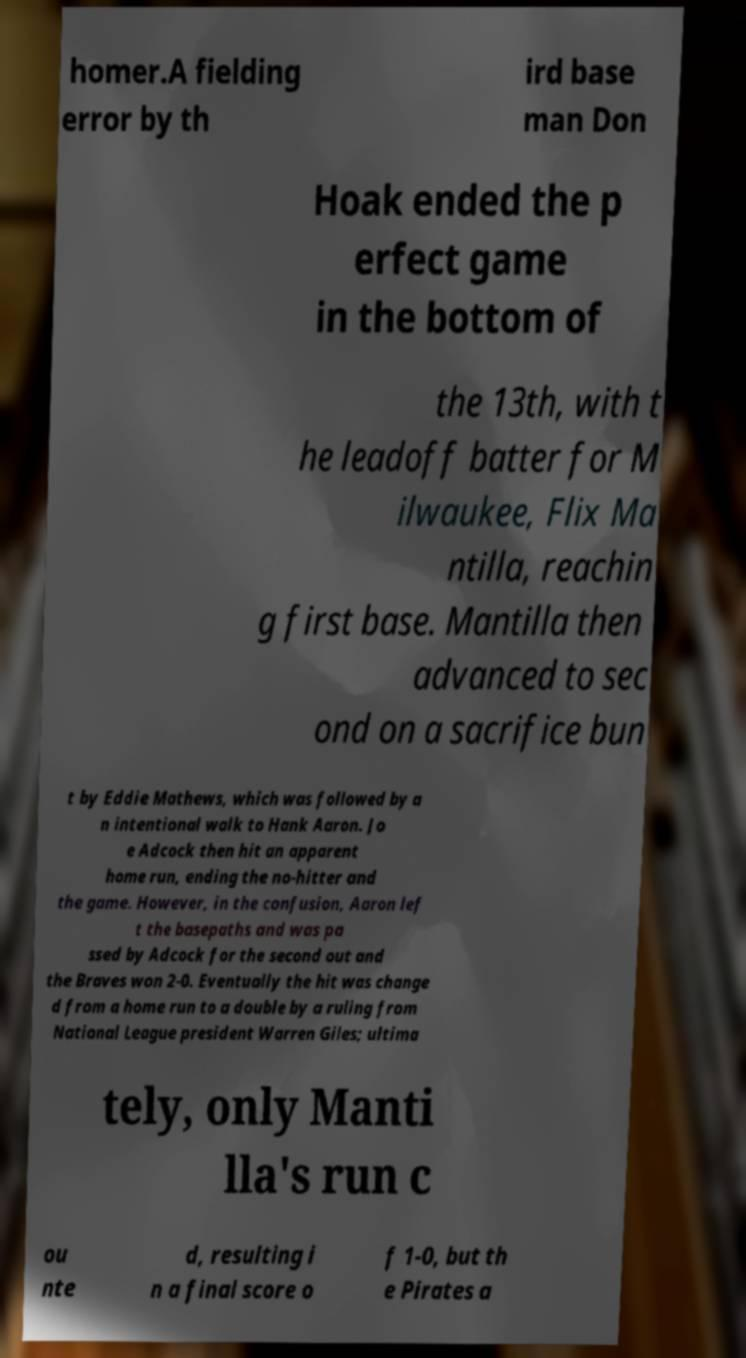For documentation purposes, I need the text within this image transcribed. Could you provide that? homer.A fielding error by th ird base man Don Hoak ended the p erfect game in the bottom of the 13th, with t he leadoff batter for M ilwaukee, Flix Ma ntilla, reachin g first base. Mantilla then advanced to sec ond on a sacrifice bun t by Eddie Mathews, which was followed by a n intentional walk to Hank Aaron. Jo e Adcock then hit an apparent home run, ending the no-hitter and the game. However, in the confusion, Aaron lef t the basepaths and was pa ssed by Adcock for the second out and the Braves won 2-0. Eventually the hit was change d from a home run to a double by a ruling from National League president Warren Giles; ultima tely, only Manti lla's run c ou nte d, resulting i n a final score o f 1-0, but th e Pirates a 